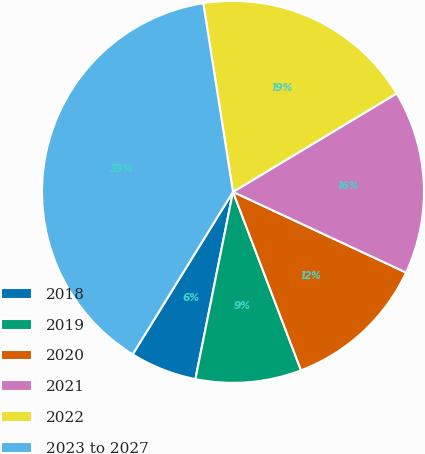Convert chart. <chart><loc_0><loc_0><loc_500><loc_500><pie_chart><fcel>2018<fcel>2019<fcel>2020<fcel>2021<fcel>2022<fcel>2023 to 2027<nl><fcel>5.65%<fcel>8.95%<fcel>12.26%<fcel>15.56%<fcel>18.87%<fcel>38.71%<nl></chart> 